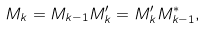Convert formula to latex. <formula><loc_0><loc_0><loc_500><loc_500>M _ { k } = M _ { k - 1 } M ^ { \prime } _ { k } = M ^ { \prime } _ { k } M ^ { * } _ { k - 1 } ,</formula> 